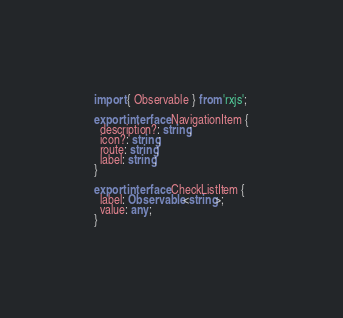<code> <loc_0><loc_0><loc_500><loc_500><_TypeScript_>import { Observable } from 'rxjs';

export interface NavigationItem {
  description?: string;
  icon?: string;
  route: string;
  label: string;
}

export interface CheckListItem {
  label: Observable<string>;
  value: any;
}
</code> 